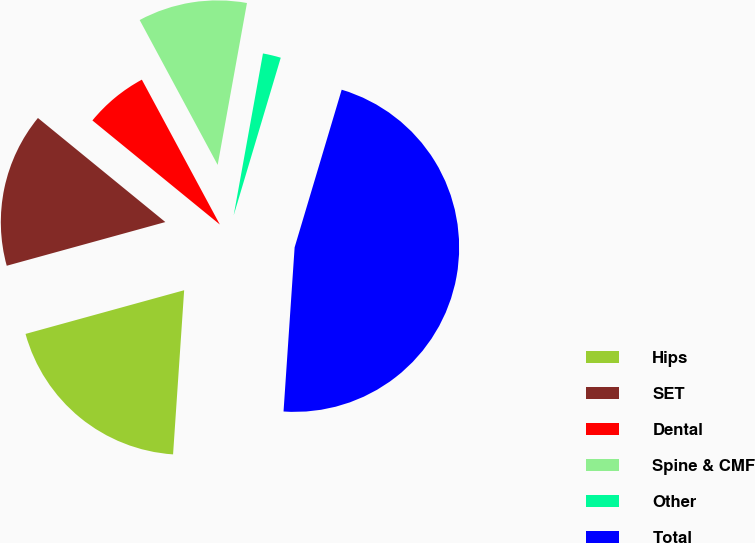Convert chart to OTSL. <chart><loc_0><loc_0><loc_500><loc_500><pie_chart><fcel>Hips<fcel>SET<fcel>Dental<fcel>Spine & CMF<fcel>Other<fcel>Total<nl><fcel>19.65%<fcel>15.18%<fcel>6.24%<fcel>10.71%<fcel>1.77%<fcel>46.46%<nl></chart> 